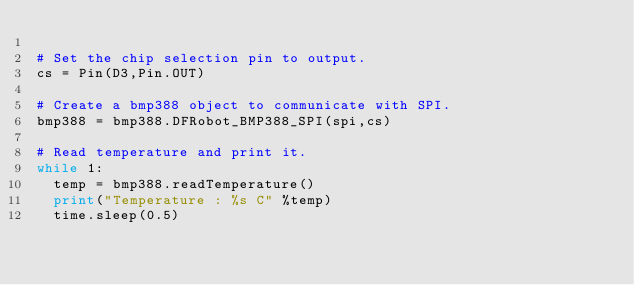Convert code to text. <code><loc_0><loc_0><loc_500><loc_500><_Python_>
# Set the chip selection pin to output.
cs = Pin(D3,Pin.OUT)

# Create a bmp388 object to communicate with SPI.
bmp388 = bmp388.DFRobot_BMP388_SPI(spi,cs)

# Read temperature and print it.
while 1:
  temp = bmp388.readTemperature()
  print("Temperature : %s C" %temp)
  time.sleep(0.5)</code> 